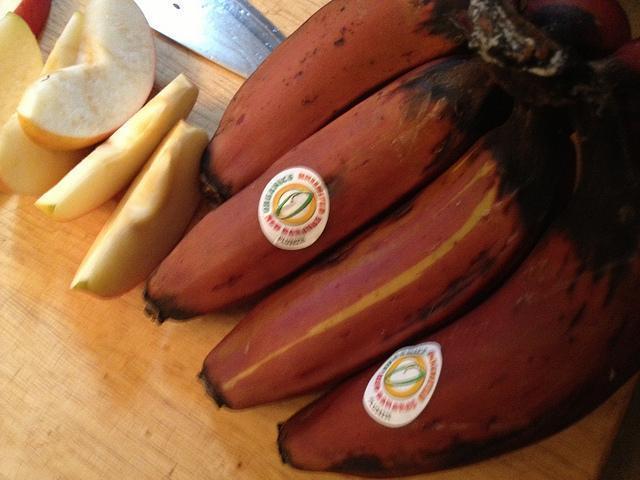How many apples are there?
Give a very brief answer. 3. How many bananas are in the photo?
Give a very brief answer. 4. 